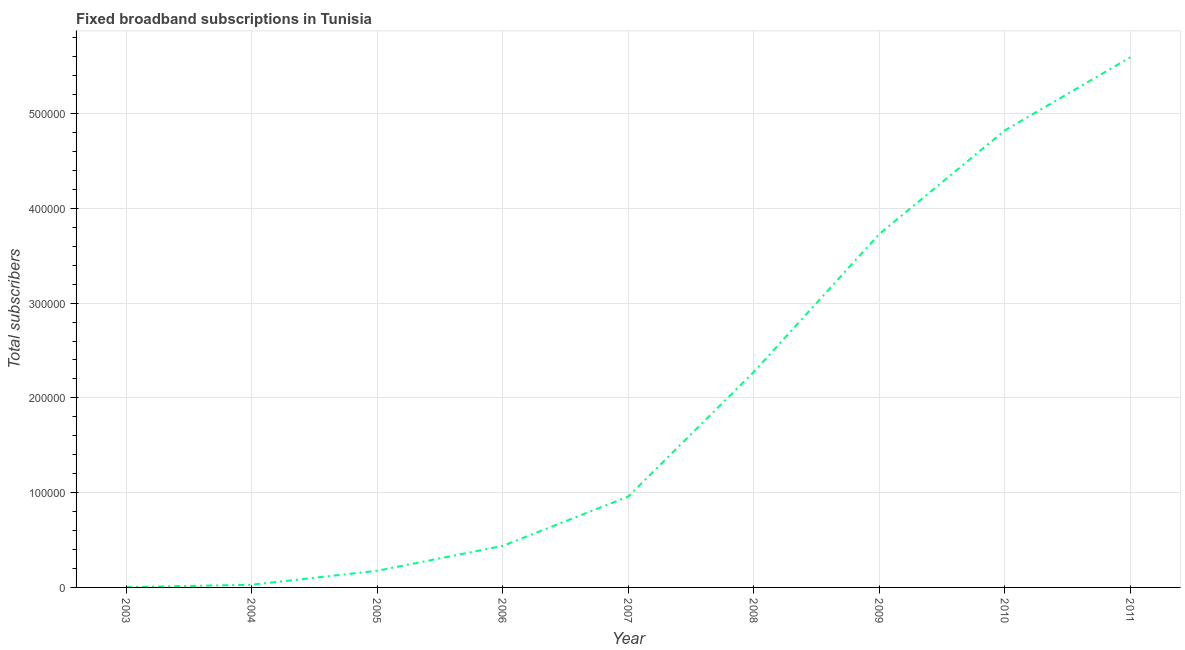What is the total number of fixed broadband subscriptions in 2011?
Make the answer very short. 5.59e+05. Across all years, what is the maximum total number of fixed broadband subscriptions?
Ensure brevity in your answer.  5.59e+05. Across all years, what is the minimum total number of fixed broadband subscriptions?
Your answer should be compact. 259. In which year was the total number of fixed broadband subscriptions maximum?
Your response must be concise. 2011. What is the sum of the total number of fixed broadband subscriptions?
Your answer should be very brief. 1.80e+06. What is the difference between the total number of fixed broadband subscriptions in 2005 and 2010?
Your answer should be compact. -4.65e+05. What is the average total number of fixed broadband subscriptions per year?
Ensure brevity in your answer.  2.00e+05. What is the median total number of fixed broadband subscriptions?
Ensure brevity in your answer.  9.59e+04. Do a majority of the years between 2011 and 2008 (inclusive) have total number of fixed broadband subscriptions greater than 120000 ?
Provide a short and direct response. Yes. What is the ratio of the total number of fixed broadband subscriptions in 2003 to that in 2007?
Keep it short and to the point. 0. Is the difference between the total number of fixed broadband subscriptions in 2005 and 2006 greater than the difference between any two years?
Your response must be concise. No. What is the difference between the highest and the second highest total number of fixed broadband subscriptions?
Make the answer very short. 7.72e+04. Is the sum of the total number of fixed broadband subscriptions in 2008 and 2009 greater than the maximum total number of fixed broadband subscriptions across all years?
Ensure brevity in your answer.  Yes. What is the difference between the highest and the lowest total number of fixed broadband subscriptions?
Provide a short and direct response. 5.59e+05. Does the total number of fixed broadband subscriptions monotonically increase over the years?
Your answer should be compact. Yes. How many lines are there?
Make the answer very short. 1. How many years are there in the graph?
Your answer should be compact. 9. What is the difference between two consecutive major ticks on the Y-axis?
Give a very brief answer. 1.00e+05. Are the values on the major ticks of Y-axis written in scientific E-notation?
Your answer should be compact. No. What is the title of the graph?
Offer a very short reply. Fixed broadband subscriptions in Tunisia. What is the label or title of the Y-axis?
Make the answer very short. Total subscribers. What is the Total subscribers in 2003?
Provide a short and direct response. 259. What is the Total subscribers in 2004?
Provide a short and direct response. 2839. What is the Total subscribers of 2005?
Offer a terse response. 1.76e+04. What is the Total subscribers in 2006?
Your response must be concise. 4.38e+04. What is the Total subscribers in 2007?
Your response must be concise. 9.59e+04. What is the Total subscribers of 2008?
Keep it short and to the point. 2.27e+05. What is the Total subscribers of 2009?
Offer a terse response. 3.73e+05. What is the Total subscribers in 2010?
Ensure brevity in your answer.  4.82e+05. What is the Total subscribers in 2011?
Provide a succinct answer. 5.59e+05. What is the difference between the Total subscribers in 2003 and 2004?
Make the answer very short. -2580. What is the difference between the Total subscribers in 2003 and 2005?
Offer a terse response. -1.73e+04. What is the difference between the Total subscribers in 2003 and 2006?
Provide a succinct answer. -4.36e+04. What is the difference between the Total subscribers in 2003 and 2007?
Offer a terse response. -9.57e+04. What is the difference between the Total subscribers in 2003 and 2008?
Provide a succinct answer. -2.27e+05. What is the difference between the Total subscribers in 2003 and 2009?
Your response must be concise. -3.73e+05. What is the difference between the Total subscribers in 2003 and 2010?
Your answer should be very brief. -4.82e+05. What is the difference between the Total subscribers in 2003 and 2011?
Your response must be concise. -5.59e+05. What is the difference between the Total subscribers in 2004 and 2005?
Provide a short and direct response. -1.47e+04. What is the difference between the Total subscribers in 2004 and 2006?
Keep it short and to the point. -4.10e+04. What is the difference between the Total subscribers in 2004 and 2007?
Offer a very short reply. -9.31e+04. What is the difference between the Total subscribers in 2004 and 2008?
Make the answer very short. -2.24e+05. What is the difference between the Total subscribers in 2004 and 2009?
Your answer should be compact. -3.70e+05. What is the difference between the Total subscribers in 2004 and 2010?
Your answer should be very brief. -4.79e+05. What is the difference between the Total subscribers in 2004 and 2011?
Ensure brevity in your answer.  -5.57e+05. What is the difference between the Total subscribers in 2005 and 2006?
Provide a short and direct response. -2.63e+04. What is the difference between the Total subscribers in 2005 and 2007?
Ensure brevity in your answer.  -7.83e+04. What is the difference between the Total subscribers in 2005 and 2008?
Provide a succinct answer. -2.10e+05. What is the difference between the Total subscribers in 2005 and 2009?
Your response must be concise. -3.55e+05. What is the difference between the Total subscribers in 2005 and 2010?
Offer a very short reply. -4.65e+05. What is the difference between the Total subscribers in 2005 and 2011?
Ensure brevity in your answer.  -5.42e+05. What is the difference between the Total subscribers in 2006 and 2007?
Give a very brief answer. -5.21e+04. What is the difference between the Total subscribers in 2006 and 2008?
Make the answer very short. -1.83e+05. What is the difference between the Total subscribers in 2006 and 2009?
Your answer should be compact. -3.29e+05. What is the difference between the Total subscribers in 2006 and 2010?
Your answer should be very brief. -4.38e+05. What is the difference between the Total subscribers in 2006 and 2011?
Make the answer very short. -5.16e+05. What is the difference between the Total subscribers in 2007 and 2008?
Keep it short and to the point. -1.31e+05. What is the difference between the Total subscribers in 2007 and 2009?
Offer a terse response. -2.77e+05. What is the difference between the Total subscribers in 2007 and 2010?
Keep it short and to the point. -3.86e+05. What is the difference between the Total subscribers in 2007 and 2011?
Keep it short and to the point. -4.63e+05. What is the difference between the Total subscribers in 2008 and 2009?
Ensure brevity in your answer.  -1.46e+05. What is the difference between the Total subscribers in 2008 and 2010?
Ensure brevity in your answer.  -2.55e+05. What is the difference between the Total subscribers in 2008 and 2011?
Your answer should be very brief. -3.32e+05. What is the difference between the Total subscribers in 2009 and 2010?
Offer a terse response. -1.09e+05. What is the difference between the Total subscribers in 2009 and 2011?
Provide a short and direct response. -1.86e+05. What is the difference between the Total subscribers in 2010 and 2011?
Ensure brevity in your answer.  -7.72e+04. What is the ratio of the Total subscribers in 2003 to that in 2004?
Offer a terse response. 0.09. What is the ratio of the Total subscribers in 2003 to that in 2005?
Keep it short and to the point. 0.01. What is the ratio of the Total subscribers in 2003 to that in 2006?
Your answer should be compact. 0.01. What is the ratio of the Total subscribers in 2003 to that in 2007?
Your answer should be compact. 0. What is the ratio of the Total subscribers in 2003 to that in 2008?
Provide a short and direct response. 0. What is the ratio of the Total subscribers in 2003 to that in 2010?
Offer a terse response. 0. What is the ratio of the Total subscribers in 2003 to that in 2011?
Your response must be concise. 0. What is the ratio of the Total subscribers in 2004 to that in 2005?
Make the answer very short. 0.16. What is the ratio of the Total subscribers in 2004 to that in 2006?
Your answer should be very brief. 0.07. What is the ratio of the Total subscribers in 2004 to that in 2008?
Keep it short and to the point. 0.01. What is the ratio of the Total subscribers in 2004 to that in 2009?
Your response must be concise. 0.01. What is the ratio of the Total subscribers in 2004 to that in 2010?
Ensure brevity in your answer.  0.01. What is the ratio of the Total subscribers in 2004 to that in 2011?
Provide a short and direct response. 0.01. What is the ratio of the Total subscribers in 2005 to that in 2006?
Offer a very short reply. 0.4. What is the ratio of the Total subscribers in 2005 to that in 2007?
Make the answer very short. 0.18. What is the ratio of the Total subscribers in 2005 to that in 2008?
Provide a short and direct response. 0.08. What is the ratio of the Total subscribers in 2005 to that in 2009?
Give a very brief answer. 0.05. What is the ratio of the Total subscribers in 2005 to that in 2010?
Provide a succinct answer. 0.04. What is the ratio of the Total subscribers in 2005 to that in 2011?
Keep it short and to the point. 0.03. What is the ratio of the Total subscribers in 2006 to that in 2007?
Offer a terse response. 0.46. What is the ratio of the Total subscribers in 2006 to that in 2008?
Your response must be concise. 0.19. What is the ratio of the Total subscribers in 2006 to that in 2009?
Give a very brief answer. 0.12. What is the ratio of the Total subscribers in 2006 to that in 2010?
Your answer should be very brief. 0.09. What is the ratio of the Total subscribers in 2006 to that in 2011?
Offer a very short reply. 0.08. What is the ratio of the Total subscribers in 2007 to that in 2008?
Give a very brief answer. 0.42. What is the ratio of the Total subscribers in 2007 to that in 2009?
Ensure brevity in your answer.  0.26. What is the ratio of the Total subscribers in 2007 to that in 2010?
Your answer should be very brief. 0.2. What is the ratio of the Total subscribers in 2007 to that in 2011?
Your answer should be compact. 0.17. What is the ratio of the Total subscribers in 2008 to that in 2009?
Give a very brief answer. 0.61. What is the ratio of the Total subscribers in 2008 to that in 2010?
Keep it short and to the point. 0.47. What is the ratio of the Total subscribers in 2008 to that in 2011?
Your answer should be compact. 0.41. What is the ratio of the Total subscribers in 2009 to that in 2010?
Keep it short and to the point. 0.77. What is the ratio of the Total subscribers in 2009 to that in 2011?
Offer a terse response. 0.67. What is the ratio of the Total subscribers in 2010 to that in 2011?
Provide a succinct answer. 0.86. 